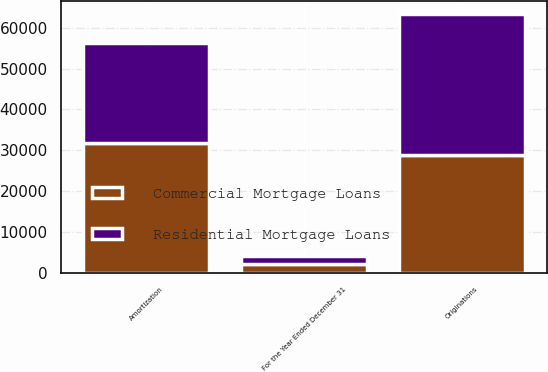<chart> <loc_0><loc_0><loc_500><loc_500><stacked_bar_chart><ecel><fcel>For the Year Ended December 31<fcel>Originations<fcel>Amortization<nl><fcel>Commercial Mortgage Loans<fcel>2017<fcel>28792<fcel>31864<nl><fcel>Residential Mortgage Loans<fcel>2017<fcel>34620<fcel>24308<nl></chart> 